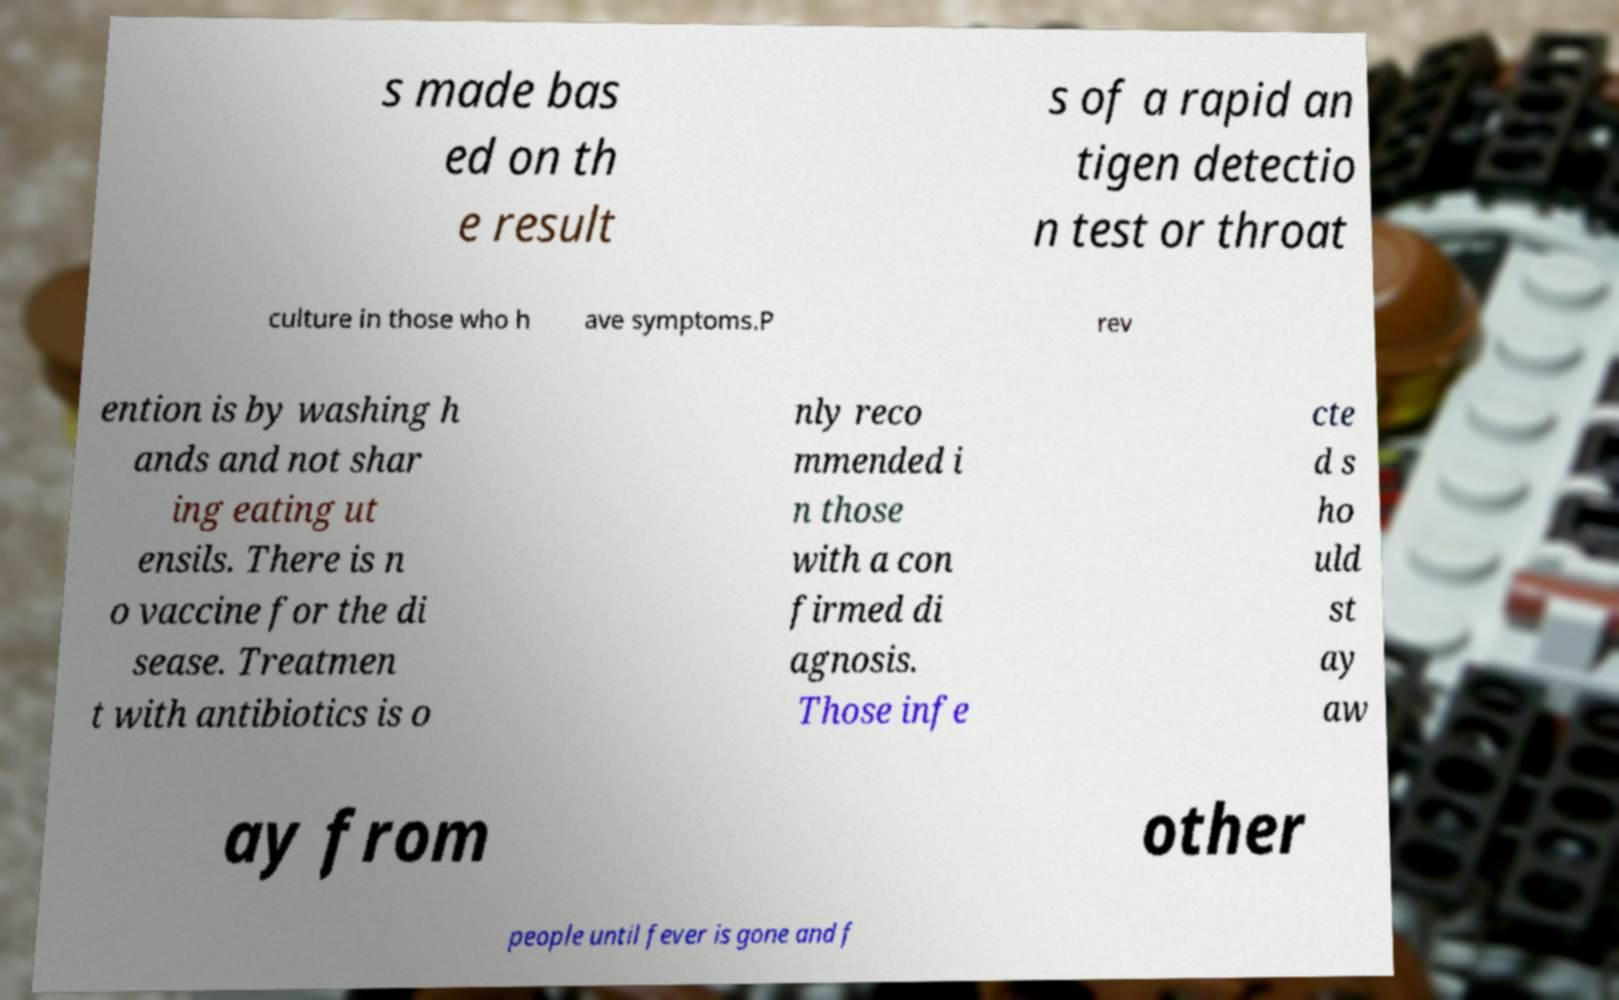Can you read and provide the text displayed in the image?This photo seems to have some interesting text. Can you extract and type it out for me? s made bas ed on th e result s of a rapid an tigen detectio n test or throat culture in those who h ave symptoms.P rev ention is by washing h ands and not shar ing eating ut ensils. There is n o vaccine for the di sease. Treatmen t with antibiotics is o nly reco mmended i n those with a con firmed di agnosis. Those infe cte d s ho uld st ay aw ay from other people until fever is gone and f 